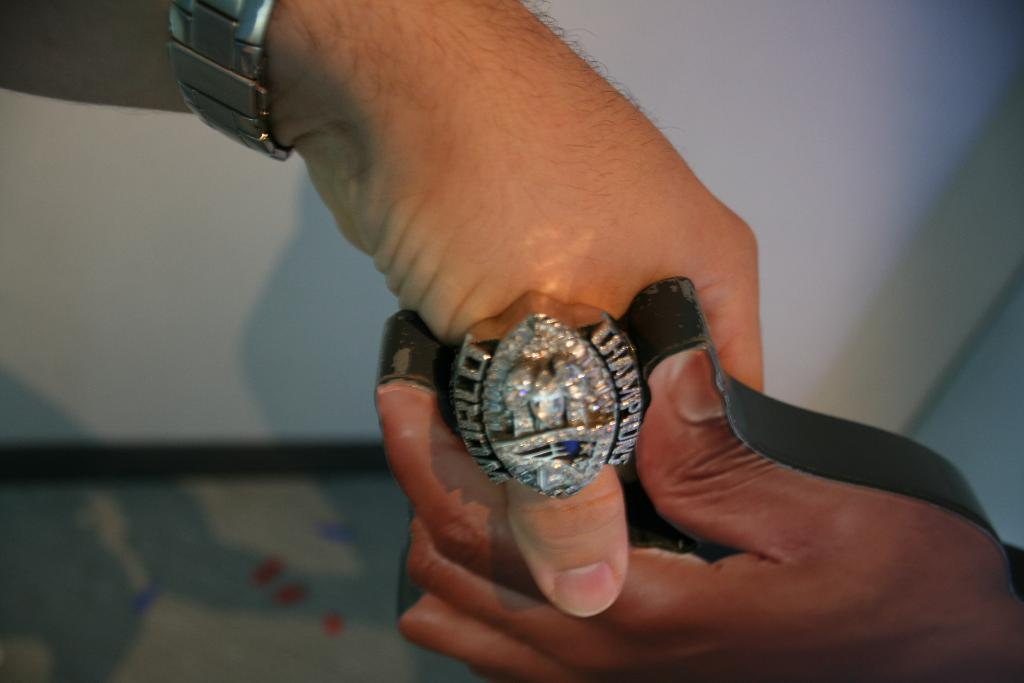<image>
Share a concise interpretation of the image provided. A man is wearing a large silver ring signifying world champions. 